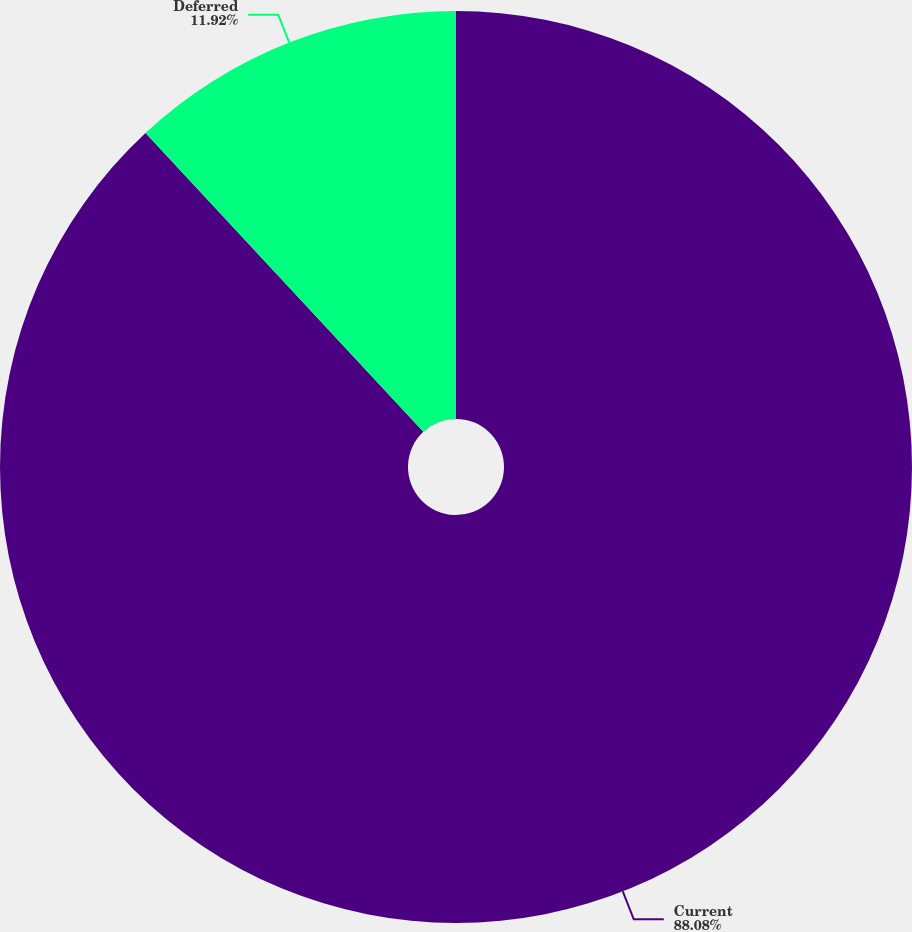Convert chart. <chart><loc_0><loc_0><loc_500><loc_500><pie_chart><fcel>Current<fcel>Deferred<nl><fcel>88.08%<fcel>11.92%<nl></chart> 